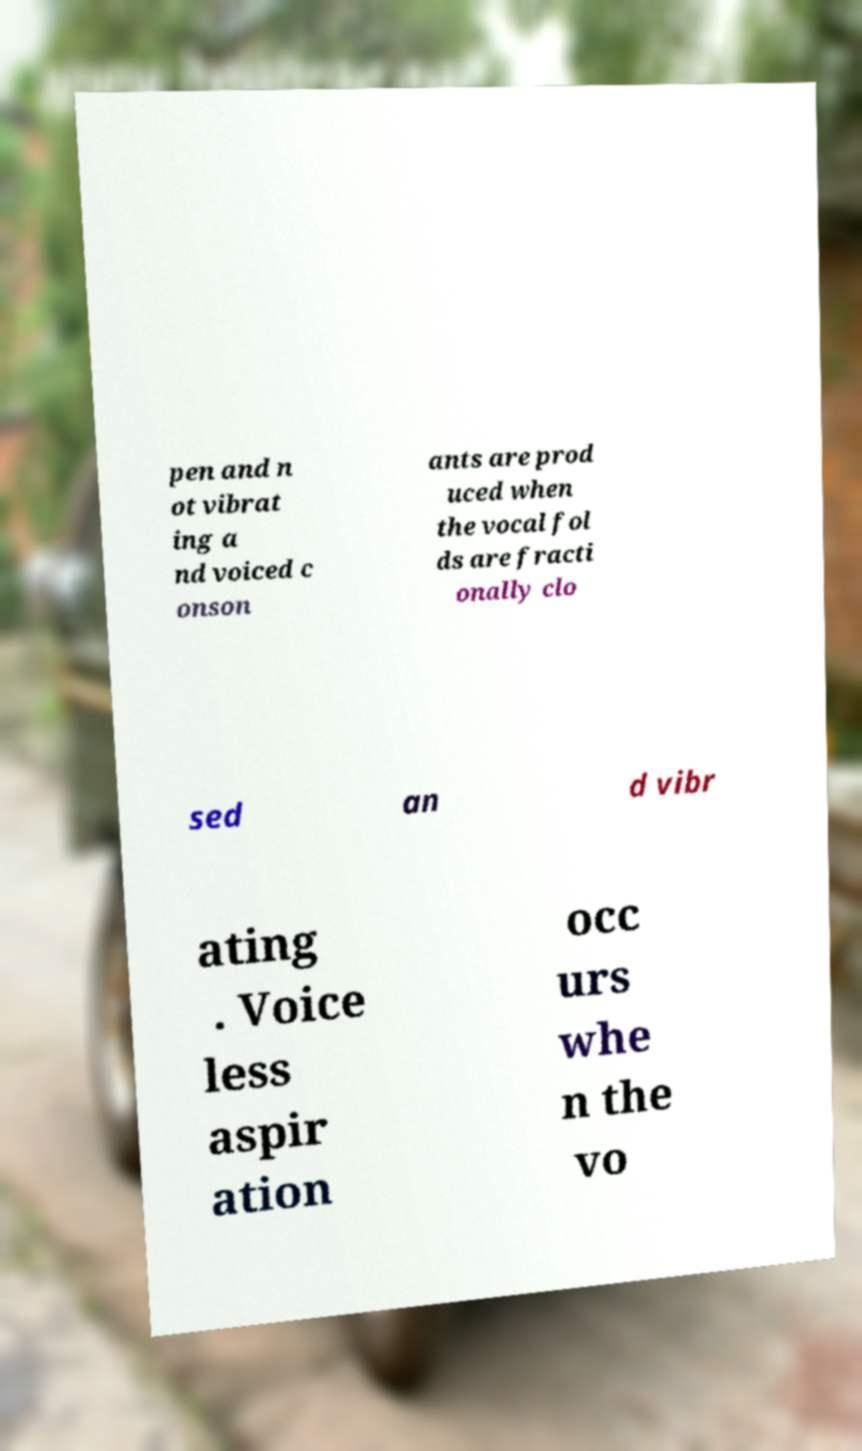For documentation purposes, I need the text within this image transcribed. Could you provide that? pen and n ot vibrat ing a nd voiced c onson ants are prod uced when the vocal fol ds are fracti onally clo sed an d vibr ating . Voice less aspir ation occ urs whe n the vo 